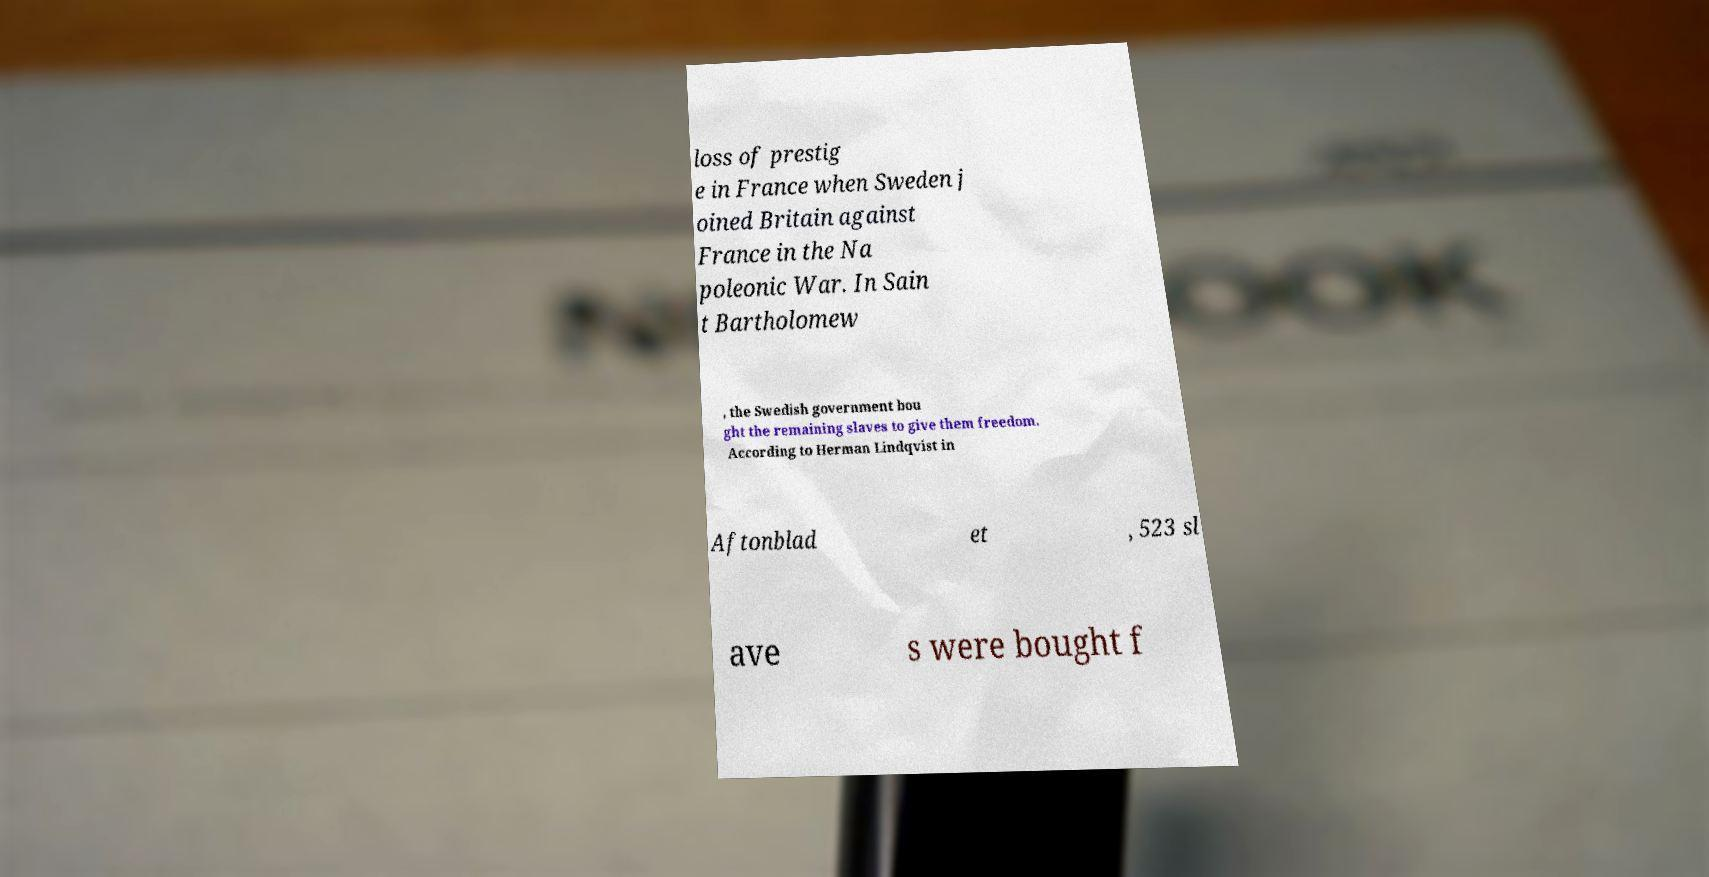I need the written content from this picture converted into text. Can you do that? loss of prestig e in France when Sweden j oined Britain against France in the Na poleonic War. In Sain t Bartholomew , the Swedish government bou ght the remaining slaves to give them freedom. According to Herman Lindqvist in Aftonblad et , 523 sl ave s were bought f 